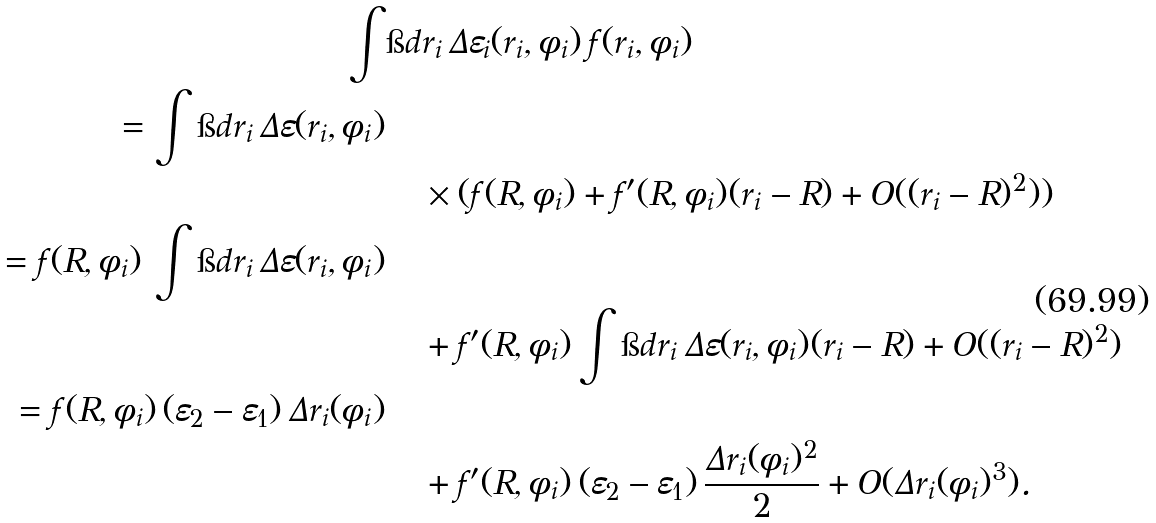<formula> <loc_0><loc_0><loc_500><loc_500>\int & \i d r _ { i } \, \Delta \varepsilon _ { i } ( r _ { i } , \phi _ { i } ) \, f ( r _ { i } , \phi _ { i } ) \\ = \int \i d r _ { i } \, \Delta \varepsilon ( r _ { i } , \phi _ { i } ) \\ & \quad \times ( f ( R , \phi _ { i } ) + f ^ { \prime } ( R , \phi _ { i } ) ( r _ { i } - R ) + O ( ( r _ { i } - R ) ^ { 2 } ) ) \\ = f ( R , \phi _ { i } ) \, \int \i d r _ { i } \, \Delta \varepsilon ( r _ { i } , \phi _ { i } ) \\ & \quad + f ^ { \prime } ( R , \phi _ { i } ) \int \i d r _ { i } \, \Delta \varepsilon ( r _ { i } , \phi _ { i } ) ( r _ { i } - R ) + O ( ( r _ { i } - R ) ^ { 2 } ) \\ = f ( R , \phi _ { i } ) \, ( \varepsilon _ { 2 } - \varepsilon _ { 1 } ) \, \Delta r _ { i } ( \phi _ { i } ) \\ & \quad + f ^ { \prime } ( R , \phi _ { i } ) \, ( \varepsilon _ { 2 } - \varepsilon _ { 1 } ) \, \frac { \Delta r _ { i } ( \phi _ { i } ) ^ { 2 } } { 2 } + O ( \Delta r _ { i } ( \phi _ { i } ) ^ { 3 } ) .</formula> 